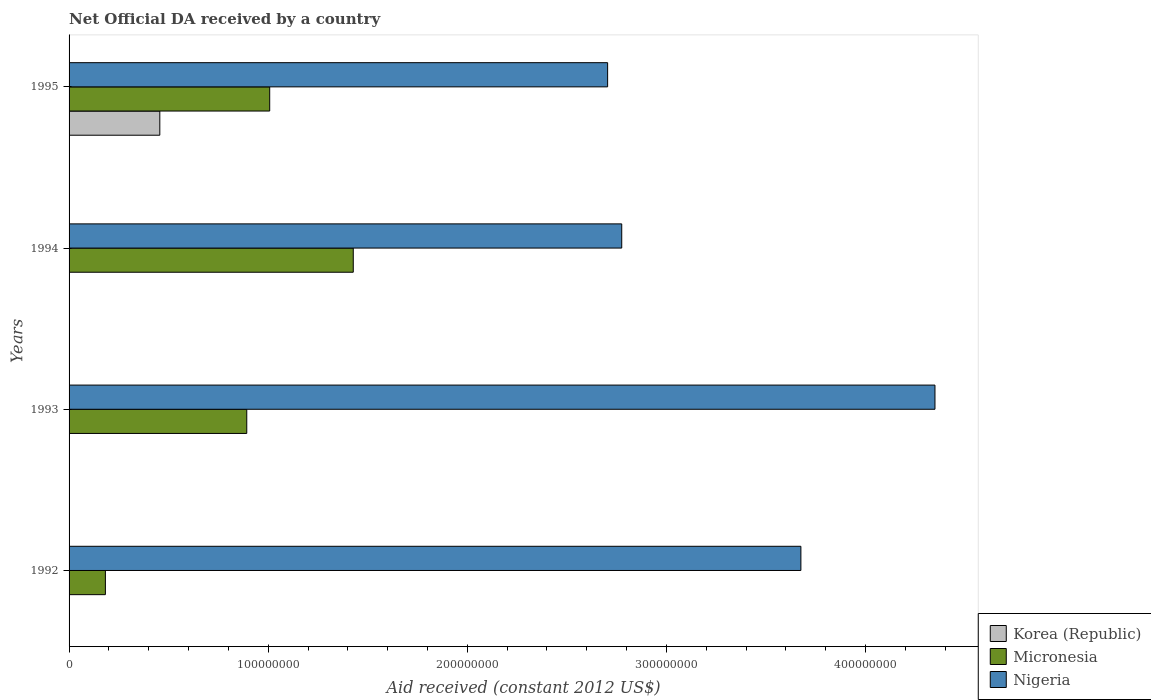How many different coloured bars are there?
Ensure brevity in your answer.  3. How many groups of bars are there?
Offer a terse response. 4. Are the number of bars per tick equal to the number of legend labels?
Your response must be concise. No. Are the number of bars on each tick of the Y-axis equal?
Your response must be concise. No. How many bars are there on the 1st tick from the top?
Offer a terse response. 3. What is the net official development assistance aid received in Nigeria in 1993?
Make the answer very short. 4.35e+08. Across all years, what is the maximum net official development assistance aid received in Micronesia?
Offer a very short reply. 1.43e+08. Across all years, what is the minimum net official development assistance aid received in Nigeria?
Offer a very short reply. 2.70e+08. What is the total net official development assistance aid received in Korea (Republic) in the graph?
Ensure brevity in your answer.  4.56e+07. What is the difference between the net official development assistance aid received in Nigeria in 1992 and that in 1995?
Ensure brevity in your answer.  9.71e+07. What is the difference between the net official development assistance aid received in Nigeria in 1994 and the net official development assistance aid received in Micronesia in 1995?
Make the answer very short. 1.77e+08. What is the average net official development assistance aid received in Nigeria per year?
Your response must be concise. 3.38e+08. In the year 1995, what is the difference between the net official development assistance aid received in Micronesia and net official development assistance aid received in Korea (Republic)?
Keep it short and to the point. 5.52e+07. In how many years, is the net official development assistance aid received in Nigeria greater than 20000000 US$?
Offer a very short reply. 4. What is the ratio of the net official development assistance aid received in Nigeria in 1994 to that in 1995?
Your answer should be very brief. 1.03. Is the net official development assistance aid received in Micronesia in 1992 less than that in 1995?
Your response must be concise. Yes. What is the difference between the highest and the second highest net official development assistance aid received in Nigeria?
Make the answer very short. 6.73e+07. What is the difference between the highest and the lowest net official development assistance aid received in Nigeria?
Offer a very short reply. 1.64e+08. Is the sum of the net official development assistance aid received in Micronesia in 1993 and 1994 greater than the maximum net official development assistance aid received in Nigeria across all years?
Ensure brevity in your answer.  No. Is it the case that in every year, the sum of the net official development assistance aid received in Micronesia and net official development assistance aid received in Korea (Republic) is greater than the net official development assistance aid received in Nigeria?
Provide a succinct answer. No. Are all the bars in the graph horizontal?
Ensure brevity in your answer.  Yes. How many years are there in the graph?
Offer a terse response. 4. Does the graph contain any zero values?
Keep it short and to the point. Yes. Where does the legend appear in the graph?
Provide a short and direct response. Bottom right. What is the title of the graph?
Keep it short and to the point. Net Official DA received by a country. Does "High income: nonOECD" appear as one of the legend labels in the graph?
Ensure brevity in your answer.  No. What is the label or title of the X-axis?
Your response must be concise. Aid received (constant 2012 US$). What is the label or title of the Y-axis?
Give a very brief answer. Years. What is the Aid received (constant 2012 US$) in Korea (Republic) in 1992?
Provide a succinct answer. 0. What is the Aid received (constant 2012 US$) of Micronesia in 1992?
Provide a short and direct response. 1.82e+07. What is the Aid received (constant 2012 US$) in Nigeria in 1992?
Your response must be concise. 3.68e+08. What is the Aid received (constant 2012 US$) in Micronesia in 1993?
Offer a terse response. 8.92e+07. What is the Aid received (constant 2012 US$) of Nigeria in 1993?
Ensure brevity in your answer.  4.35e+08. What is the Aid received (constant 2012 US$) of Korea (Republic) in 1994?
Provide a short and direct response. 0. What is the Aid received (constant 2012 US$) of Micronesia in 1994?
Give a very brief answer. 1.43e+08. What is the Aid received (constant 2012 US$) in Nigeria in 1994?
Your answer should be very brief. 2.78e+08. What is the Aid received (constant 2012 US$) in Korea (Republic) in 1995?
Provide a short and direct response. 4.56e+07. What is the Aid received (constant 2012 US$) of Micronesia in 1995?
Your answer should be very brief. 1.01e+08. What is the Aid received (constant 2012 US$) of Nigeria in 1995?
Give a very brief answer. 2.70e+08. Across all years, what is the maximum Aid received (constant 2012 US$) of Korea (Republic)?
Provide a short and direct response. 4.56e+07. Across all years, what is the maximum Aid received (constant 2012 US$) in Micronesia?
Your answer should be compact. 1.43e+08. Across all years, what is the maximum Aid received (constant 2012 US$) in Nigeria?
Offer a very short reply. 4.35e+08. Across all years, what is the minimum Aid received (constant 2012 US$) in Micronesia?
Your answer should be very brief. 1.82e+07. Across all years, what is the minimum Aid received (constant 2012 US$) in Nigeria?
Give a very brief answer. 2.70e+08. What is the total Aid received (constant 2012 US$) of Korea (Republic) in the graph?
Give a very brief answer. 4.56e+07. What is the total Aid received (constant 2012 US$) of Micronesia in the graph?
Provide a short and direct response. 3.51e+08. What is the total Aid received (constant 2012 US$) of Nigeria in the graph?
Make the answer very short. 1.35e+09. What is the difference between the Aid received (constant 2012 US$) in Micronesia in 1992 and that in 1993?
Ensure brevity in your answer.  -7.10e+07. What is the difference between the Aid received (constant 2012 US$) of Nigeria in 1992 and that in 1993?
Provide a succinct answer. -6.73e+07. What is the difference between the Aid received (constant 2012 US$) of Micronesia in 1992 and that in 1994?
Keep it short and to the point. -1.24e+08. What is the difference between the Aid received (constant 2012 US$) in Nigeria in 1992 and that in 1994?
Provide a short and direct response. 9.00e+07. What is the difference between the Aid received (constant 2012 US$) of Micronesia in 1992 and that in 1995?
Your answer should be compact. -8.25e+07. What is the difference between the Aid received (constant 2012 US$) of Nigeria in 1992 and that in 1995?
Your response must be concise. 9.71e+07. What is the difference between the Aid received (constant 2012 US$) in Micronesia in 1993 and that in 1994?
Offer a very short reply. -5.35e+07. What is the difference between the Aid received (constant 2012 US$) in Nigeria in 1993 and that in 1994?
Your answer should be very brief. 1.57e+08. What is the difference between the Aid received (constant 2012 US$) in Micronesia in 1993 and that in 1995?
Make the answer very short. -1.15e+07. What is the difference between the Aid received (constant 2012 US$) in Nigeria in 1993 and that in 1995?
Offer a terse response. 1.64e+08. What is the difference between the Aid received (constant 2012 US$) in Micronesia in 1994 and that in 1995?
Provide a short and direct response. 4.20e+07. What is the difference between the Aid received (constant 2012 US$) in Nigeria in 1994 and that in 1995?
Give a very brief answer. 7.09e+06. What is the difference between the Aid received (constant 2012 US$) in Micronesia in 1992 and the Aid received (constant 2012 US$) in Nigeria in 1993?
Offer a very short reply. -4.17e+08. What is the difference between the Aid received (constant 2012 US$) of Micronesia in 1992 and the Aid received (constant 2012 US$) of Nigeria in 1994?
Your answer should be very brief. -2.59e+08. What is the difference between the Aid received (constant 2012 US$) in Micronesia in 1992 and the Aid received (constant 2012 US$) in Nigeria in 1995?
Provide a short and direct response. -2.52e+08. What is the difference between the Aid received (constant 2012 US$) of Micronesia in 1993 and the Aid received (constant 2012 US$) of Nigeria in 1994?
Offer a terse response. -1.88e+08. What is the difference between the Aid received (constant 2012 US$) in Micronesia in 1993 and the Aid received (constant 2012 US$) in Nigeria in 1995?
Keep it short and to the point. -1.81e+08. What is the difference between the Aid received (constant 2012 US$) in Micronesia in 1994 and the Aid received (constant 2012 US$) in Nigeria in 1995?
Make the answer very short. -1.28e+08. What is the average Aid received (constant 2012 US$) in Korea (Republic) per year?
Your answer should be very brief. 1.14e+07. What is the average Aid received (constant 2012 US$) in Micronesia per year?
Your response must be concise. 8.77e+07. What is the average Aid received (constant 2012 US$) of Nigeria per year?
Provide a succinct answer. 3.38e+08. In the year 1992, what is the difference between the Aid received (constant 2012 US$) of Micronesia and Aid received (constant 2012 US$) of Nigeria?
Make the answer very short. -3.49e+08. In the year 1993, what is the difference between the Aid received (constant 2012 US$) of Micronesia and Aid received (constant 2012 US$) of Nigeria?
Your response must be concise. -3.46e+08. In the year 1994, what is the difference between the Aid received (constant 2012 US$) of Micronesia and Aid received (constant 2012 US$) of Nigeria?
Provide a short and direct response. -1.35e+08. In the year 1995, what is the difference between the Aid received (constant 2012 US$) of Korea (Republic) and Aid received (constant 2012 US$) of Micronesia?
Your response must be concise. -5.52e+07. In the year 1995, what is the difference between the Aid received (constant 2012 US$) in Korea (Republic) and Aid received (constant 2012 US$) in Nigeria?
Give a very brief answer. -2.25e+08. In the year 1995, what is the difference between the Aid received (constant 2012 US$) in Micronesia and Aid received (constant 2012 US$) in Nigeria?
Offer a terse response. -1.70e+08. What is the ratio of the Aid received (constant 2012 US$) in Micronesia in 1992 to that in 1993?
Provide a short and direct response. 0.2. What is the ratio of the Aid received (constant 2012 US$) in Nigeria in 1992 to that in 1993?
Provide a short and direct response. 0.85. What is the ratio of the Aid received (constant 2012 US$) of Micronesia in 1992 to that in 1994?
Keep it short and to the point. 0.13. What is the ratio of the Aid received (constant 2012 US$) of Nigeria in 1992 to that in 1994?
Ensure brevity in your answer.  1.32. What is the ratio of the Aid received (constant 2012 US$) in Micronesia in 1992 to that in 1995?
Provide a succinct answer. 0.18. What is the ratio of the Aid received (constant 2012 US$) of Nigeria in 1992 to that in 1995?
Offer a terse response. 1.36. What is the ratio of the Aid received (constant 2012 US$) of Micronesia in 1993 to that in 1994?
Give a very brief answer. 0.63. What is the ratio of the Aid received (constant 2012 US$) of Nigeria in 1993 to that in 1994?
Your response must be concise. 1.57. What is the ratio of the Aid received (constant 2012 US$) in Micronesia in 1993 to that in 1995?
Your answer should be very brief. 0.89. What is the ratio of the Aid received (constant 2012 US$) of Nigeria in 1993 to that in 1995?
Offer a very short reply. 1.61. What is the ratio of the Aid received (constant 2012 US$) in Micronesia in 1994 to that in 1995?
Your answer should be compact. 1.42. What is the ratio of the Aid received (constant 2012 US$) of Nigeria in 1994 to that in 1995?
Give a very brief answer. 1.03. What is the difference between the highest and the second highest Aid received (constant 2012 US$) in Micronesia?
Offer a terse response. 4.20e+07. What is the difference between the highest and the second highest Aid received (constant 2012 US$) in Nigeria?
Offer a very short reply. 6.73e+07. What is the difference between the highest and the lowest Aid received (constant 2012 US$) of Korea (Republic)?
Provide a short and direct response. 4.56e+07. What is the difference between the highest and the lowest Aid received (constant 2012 US$) in Micronesia?
Your answer should be compact. 1.24e+08. What is the difference between the highest and the lowest Aid received (constant 2012 US$) of Nigeria?
Keep it short and to the point. 1.64e+08. 